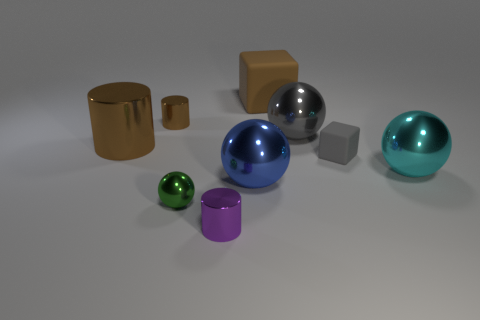Subtract all yellow balls. Subtract all gray cubes. How many balls are left? 4 Subtract all cylinders. How many objects are left? 6 Add 2 blue metallic spheres. How many blue metallic spheres are left? 3 Add 5 purple shiny objects. How many purple shiny objects exist? 6 Subtract 0 green blocks. How many objects are left? 9 Subtract all blue metallic balls. Subtract all blue metallic objects. How many objects are left? 7 